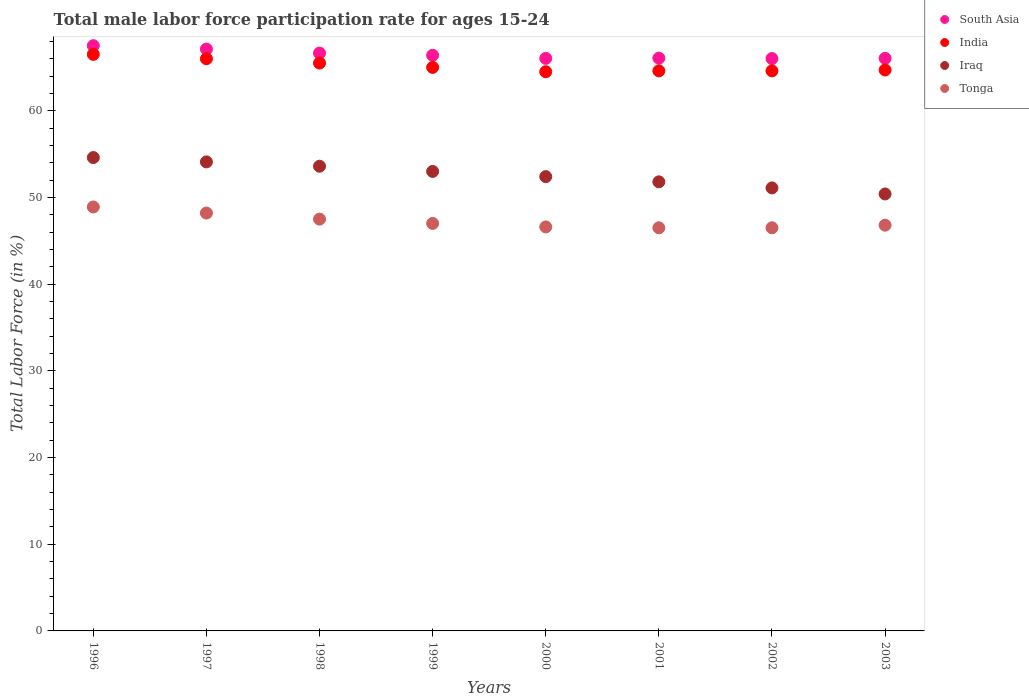What is the male labor force participation rate in Tonga in 1996?
Your answer should be compact. 48.9. Across all years, what is the maximum male labor force participation rate in Iraq?
Give a very brief answer. 54.6. Across all years, what is the minimum male labor force participation rate in Tonga?
Your response must be concise. 46.5. In which year was the male labor force participation rate in South Asia minimum?
Make the answer very short. 2002. What is the total male labor force participation rate in Iraq in the graph?
Give a very brief answer. 421. What is the difference between the male labor force participation rate in India in 2000 and the male labor force participation rate in Tonga in 1996?
Ensure brevity in your answer.  15.6. What is the average male labor force participation rate in South Asia per year?
Your response must be concise. 66.48. In the year 2000, what is the difference between the male labor force participation rate in Tonga and male labor force participation rate in Iraq?
Offer a very short reply. -5.8. What is the ratio of the male labor force participation rate in Iraq in 2000 to that in 2001?
Ensure brevity in your answer.  1.01. Is the male labor force participation rate in Tonga in 1999 less than that in 2002?
Ensure brevity in your answer.  No. Is the difference between the male labor force participation rate in Tonga in 1996 and 1999 greater than the difference between the male labor force participation rate in Iraq in 1996 and 1999?
Provide a succinct answer. Yes. What is the difference between the highest and the second highest male labor force participation rate in South Asia?
Ensure brevity in your answer.  0.39. What is the difference between the highest and the lowest male labor force participation rate in Iraq?
Ensure brevity in your answer.  4.2. Is the sum of the male labor force participation rate in India in 1999 and 2000 greater than the maximum male labor force participation rate in Tonga across all years?
Give a very brief answer. Yes. Is it the case that in every year, the sum of the male labor force participation rate in South Asia and male labor force participation rate in Tonga  is greater than the sum of male labor force participation rate in India and male labor force participation rate in Iraq?
Offer a very short reply. Yes. Does the male labor force participation rate in Iraq monotonically increase over the years?
Give a very brief answer. No. Is the male labor force participation rate in India strictly greater than the male labor force participation rate in South Asia over the years?
Offer a terse response. No. Is the male labor force participation rate in India strictly less than the male labor force participation rate in South Asia over the years?
Make the answer very short. Yes. What is the difference between two consecutive major ticks on the Y-axis?
Provide a short and direct response. 10. Are the values on the major ticks of Y-axis written in scientific E-notation?
Your answer should be very brief. No. How many legend labels are there?
Your answer should be very brief. 4. What is the title of the graph?
Provide a short and direct response. Total male labor force participation rate for ages 15-24. What is the Total Labor Force (in %) in South Asia in 1996?
Your response must be concise. 67.5. What is the Total Labor Force (in %) of India in 1996?
Provide a short and direct response. 66.5. What is the Total Labor Force (in %) of Iraq in 1996?
Make the answer very short. 54.6. What is the Total Labor Force (in %) in Tonga in 1996?
Keep it short and to the point. 48.9. What is the Total Labor Force (in %) in South Asia in 1997?
Give a very brief answer. 67.11. What is the Total Labor Force (in %) of Iraq in 1997?
Offer a very short reply. 54.1. What is the Total Labor Force (in %) of Tonga in 1997?
Your response must be concise. 48.2. What is the Total Labor Force (in %) in South Asia in 1998?
Provide a succinct answer. 66.65. What is the Total Labor Force (in %) in India in 1998?
Offer a very short reply. 65.5. What is the Total Labor Force (in %) of Iraq in 1998?
Make the answer very short. 53.6. What is the Total Labor Force (in %) of Tonga in 1998?
Your answer should be very brief. 47.5. What is the Total Labor Force (in %) of South Asia in 1999?
Your response must be concise. 66.4. What is the Total Labor Force (in %) of India in 1999?
Your answer should be compact. 65. What is the Total Labor Force (in %) in Iraq in 1999?
Give a very brief answer. 53. What is the Total Labor Force (in %) in Tonga in 1999?
Provide a short and direct response. 47. What is the Total Labor Force (in %) of South Asia in 2000?
Your answer should be compact. 66.04. What is the Total Labor Force (in %) of India in 2000?
Keep it short and to the point. 64.5. What is the Total Labor Force (in %) in Iraq in 2000?
Ensure brevity in your answer.  52.4. What is the Total Labor Force (in %) in Tonga in 2000?
Provide a succinct answer. 46.6. What is the Total Labor Force (in %) in South Asia in 2001?
Give a very brief answer. 66.07. What is the Total Labor Force (in %) of India in 2001?
Offer a terse response. 64.6. What is the Total Labor Force (in %) of Iraq in 2001?
Give a very brief answer. 51.8. What is the Total Labor Force (in %) of Tonga in 2001?
Make the answer very short. 46.5. What is the Total Labor Force (in %) in South Asia in 2002?
Give a very brief answer. 66.02. What is the Total Labor Force (in %) of India in 2002?
Your answer should be very brief. 64.6. What is the Total Labor Force (in %) in Iraq in 2002?
Ensure brevity in your answer.  51.1. What is the Total Labor Force (in %) of Tonga in 2002?
Offer a very short reply. 46.5. What is the Total Labor Force (in %) of South Asia in 2003?
Make the answer very short. 66.04. What is the Total Labor Force (in %) of India in 2003?
Offer a very short reply. 64.7. What is the Total Labor Force (in %) in Iraq in 2003?
Offer a terse response. 50.4. What is the Total Labor Force (in %) of Tonga in 2003?
Your answer should be compact. 46.8. Across all years, what is the maximum Total Labor Force (in %) in South Asia?
Provide a succinct answer. 67.5. Across all years, what is the maximum Total Labor Force (in %) in India?
Your response must be concise. 66.5. Across all years, what is the maximum Total Labor Force (in %) in Iraq?
Ensure brevity in your answer.  54.6. Across all years, what is the maximum Total Labor Force (in %) in Tonga?
Give a very brief answer. 48.9. Across all years, what is the minimum Total Labor Force (in %) in South Asia?
Your response must be concise. 66.02. Across all years, what is the minimum Total Labor Force (in %) in India?
Keep it short and to the point. 64.5. Across all years, what is the minimum Total Labor Force (in %) of Iraq?
Make the answer very short. 50.4. Across all years, what is the minimum Total Labor Force (in %) in Tonga?
Offer a terse response. 46.5. What is the total Total Labor Force (in %) in South Asia in the graph?
Provide a short and direct response. 531.83. What is the total Total Labor Force (in %) in India in the graph?
Make the answer very short. 521.4. What is the total Total Labor Force (in %) in Iraq in the graph?
Provide a short and direct response. 421. What is the total Total Labor Force (in %) in Tonga in the graph?
Provide a short and direct response. 378. What is the difference between the Total Labor Force (in %) in South Asia in 1996 and that in 1997?
Your answer should be very brief. 0.39. What is the difference between the Total Labor Force (in %) of Iraq in 1996 and that in 1997?
Offer a very short reply. 0.5. What is the difference between the Total Labor Force (in %) of South Asia in 1996 and that in 1998?
Provide a short and direct response. 0.86. What is the difference between the Total Labor Force (in %) of South Asia in 1996 and that in 1999?
Offer a terse response. 1.11. What is the difference between the Total Labor Force (in %) of Tonga in 1996 and that in 1999?
Give a very brief answer. 1.9. What is the difference between the Total Labor Force (in %) in South Asia in 1996 and that in 2000?
Provide a succinct answer. 1.47. What is the difference between the Total Labor Force (in %) of South Asia in 1996 and that in 2001?
Provide a short and direct response. 1.43. What is the difference between the Total Labor Force (in %) of India in 1996 and that in 2001?
Your response must be concise. 1.9. What is the difference between the Total Labor Force (in %) of Iraq in 1996 and that in 2001?
Ensure brevity in your answer.  2.8. What is the difference between the Total Labor Force (in %) of South Asia in 1996 and that in 2002?
Keep it short and to the point. 1.49. What is the difference between the Total Labor Force (in %) of Tonga in 1996 and that in 2002?
Your answer should be very brief. 2.4. What is the difference between the Total Labor Force (in %) of South Asia in 1996 and that in 2003?
Give a very brief answer. 1.46. What is the difference between the Total Labor Force (in %) in India in 1996 and that in 2003?
Give a very brief answer. 1.8. What is the difference between the Total Labor Force (in %) of Tonga in 1996 and that in 2003?
Keep it short and to the point. 2.1. What is the difference between the Total Labor Force (in %) in South Asia in 1997 and that in 1998?
Make the answer very short. 0.46. What is the difference between the Total Labor Force (in %) in South Asia in 1997 and that in 1999?
Your answer should be very brief. 0.72. What is the difference between the Total Labor Force (in %) in India in 1997 and that in 1999?
Your response must be concise. 1. What is the difference between the Total Labor Force (in %) of Tonga in 1997 and that in 1999?
Offer a very short reply. 1.2. What is the difference between the Total Labor Force (in %) of South Asia in 1997 and that in 2000?
Offer a terse response. 1.07. What is the difference between the Total Labor Force (in %) in India in 1997 and that in 2000?
Provide a succinct answer. 1.5. What is the difference between the Total Labor Force (in %) of South Asia in 1997 and that in 2001?
Offer a terse response. 1.04. What is the difference between the Total Labor Force (in %) of India in 1997 and that in 2001?
Make the answer very short. 1.4. What is the difference between the Total Labor Force (in %) of Tonga in 1997 and that in 2001?
Provide a short and direct response. 1.7. What is the difference between the Total Labor Force (in %) in South Asia in 1997 and that in 2002?
Provide a short and direct response. 1.09. What is the difference between the Total Labor Force (in %) of South Asia in 1997 and that in 2003?
Provide a short and direct response. 1.07. What is the difference between the Total Labor Force (in %) in India in 1997 and that in 2003?
Give a very brief answer. 1.3. What is the difference between the Total Labor Force (in %) of South Asia in 1998 and that in 1999?
Provide a succinct answer. 0.25. What is the difference between the Total Labor Force (in %) of South Asia in 1998 and that in 2000?
Keep it short and to the point. 0.61. What is the difference between the Total Labor Force (in %) of Iraq in 1998 and that in 2000?
Your response must be concise. 1.2. What is the difference between the Total Labor Force (in %) in South Asia in 1998 and that in 2001?
Your response must be concise. 0.58. What is the difference between the Total Labor Force (in %) of India in 1998 and that in 2001?
Give a very brief answer. 0.9. What is the difference between the Total Labor Force (in %) of Iraq in 1998 and that in 2001?
Keep it short and to the point. 1.8. What is the difference between the Total Labor Force (in %) of South Asia in 1998 and that in 2002?
Provide a short and direct response. 0.63. What is the difference between the Total Labor Force (in %) in Iraq in 1998 and that in 2002?
Provide a succinct answer. 2.5. What is the difference between the Total Labor Force (in %) of South Asia in 1998 and that in 2003?
Your response must be concise. 0.61. What is the difference between the Total Labor Force (in %) in Iraq in 1998 and that in 2003?
Provide a short and direct response. 3.2. What is the difference between the Total Labor Force (in %) in South Asia in 1999 and that in 2000?
Your answer should be compact. 0.36. What is the difference between the Total Labor Force (in %) of India in 1999 and that in 2000?
Your answer should be very brief. 0.5. What is the difference between the Total Labor Force (in %) in Iraq in 1999 and that in 2000?
Give a very brief answer. 0.6. What is the difference between the Total Labor Force (in %) of Tonga in 1999 and that in 2000?
Give a very brief answer. 0.4. What is the difference between the Total Labor Force (in %) of South Asia in 1999 and that in 2001?
Offer a very short reply. 0.33. What is the difference between the Total Labor Force (in %) in South Asia in 1999 and that in 2002?
Your response must be concise. 0.38. What is the difference between the Total Labor Force (in %) of India in 1999 and that in 2002?
Make the answer very short. 0.4. What is the difference between the Total Labor Force (in %) of Tonga in 1999 and that in 2002?
Provide a short and direct response. 0.5. What is the difference between the Total Labor Force (in %) of South Asia in 1999 and that in 2003?
Your answer should be compact. 0.35. What is the difference between the Total Labor Force (in %) in India in 1999 and that in 2003?
Ensure brevity in your answer.  0.3. What is the difference between the Total Labor Force (in %) in Iraq in 1999 and that in 2003?
Ensure brevity in your answer.  2.6. What is the difference between the Total Labor Force (in %) of Tonga in 1999 and that in 2003?
Offer a terse response. 0.2. What is the difference between the Total Labor Force (in %) in South Asia in 2000 and that in 2001?
Offer a terse response. -0.03. What is the difference between the Total Labor Force (in %) in India in 2000 and that in 2001?
Your answer should be compact. -0.1. What is the difference between the Total Labor Force (in %) of Iraq in 2000 and that in 2001?
Offer a terse response. 0.6. What is the difference between the Total Labor Force (in %) of Tonga in 2000 and that in 2001?
Give a very brief answer. 0.1. What is the difference between the Total Labor Force (in %) in South Asia in 2000 and that in 2002?
Offer a terse response. 0.02. What is the difference between the Total Labor Force (in %) in India in 2000 and that in 2002?
Provide a succinct answer. -0.1. What is the difference between the Total Labor Force (in %) in Iraq in 2000 and that in 2002?
Make the answer very short. 1.3. What is the difference between the Total Labor Force (in %) in Tonga in 2000 and that in 2002?
Make the answer very short. 0.1. What is the difference between the Total Labor Force (in %) in South Asia in 2000 and that in 2003?
Provide a succinct answer. -0. What is the difference between the Total Labor Force (in %) in Iraq in 2000 and that in 2003?
Your response must be concise. 2. What is the difference between the Total Labor Force (in %) in South Asia in 2001 and that in 2002?
Make the answer very short. 0.05. What is the difference between the Total Labor Force (in %) of Iraq in 2001 and that in 2002?
Keep it short and to the point. 0.7. What is the difference between the Total Labor Force (in %) of South Asia in 2001 and that in 2003?
Keep it short and to the point. 0.03. What is the difference between the Total Labor Force (in %) of Iraq in 2001 and that in 2003?
Your response must be concise. 1.4. What is the difference between the Total Labor Force (in %) in Tonga in 2001 and that in 2003?
Ensure brevity in your answer.  -0.3. What is the difference between the Total Labor Force (in %) in South Asia in 2002 and that in 2003?
Offer a very short reply. -0.02. What is the difference between the Total Labor Force (in %) in India in 2002 and that in 2003?
Provide a short and direct response. -0.1. What is the difference between the Total Labor Force (in %) in South Asia in 1996 and the Total Labor Force (in %) in India in 1997?
Your answer should be compact. 1.5. What is the difference between the Total Labor Force (in %) of South Asia in 1996 and the Total Labor Force (in %) of Iraq in 1997?
Make the answer very short. 13.4. What is the difference between the Total Labor Force (in %) of South Asia in 1996 and the Total Labor Force (in %) of Tonga in 1997?
Give a very brief answer. 19.3. What is the difference between the Total Labor Force (in %) of India in 1996 and the Total Labor Force (in %) of Tonga in 1997?
Offer a very short reply. 18.3. What is the difference between the Total Labor Force (in %) in South Asia in 1996 and the Total Labor Force (in %) in India in 1998?
Your response must be concise. 2. What is the difference between the Total Labor Force (in %) of South Asia in 1996 and the Total Labor Force (in %) of Iraq in 1998?
Provide a short and direct response. 13.9. What is the difference between the Total Labor Force (in %) in South Asia in 1996 and the Total Labor Force (in %) in Tonga in 1998?
Your response must be concise. 20. What is the difference between the Total Labor Force (in %) of India in 1996 and the Total Labor Force (in %) of Iraq in 1998?
Offer a very short reply. 12.9. What is the difference between the Total Labor Force (in %) in South Asia in 1996 and the Total Labor Force (in %) in India in 1999?
Make the answer very short. 2.5. What is the difference between the Total Labor Force (in %) in South Asia in 1996 and the Total Labor Force (in %) in Iraq in 1999?
Your response must be concise. 14.5. What is the difference between the Total Labor Force (in %) of South Asia in 1996 and the Total Labor Force (in %) of Tonga in 1999?
Keep it short and to the point. 20.5. What is the difference between the Total Labor Force (in %) of India in 1996 and the Total Labor Force (in %) of Tonga in 1999?
Your response must be concise. 19.5. What is the difference between the Total Labor Force (in %) of Iraq in 1996 and the Total Labor Force (in %) of Tonga in 1999?
Provide a short and direct response. 7.6. What is the difference between the Total Labor Force (in %) in South Asia in 1996 and the Total Labor Force (in %) in India in 2000?
Give a very brief answer. 3. What is the difference between the Total Labor Force (in %) in South Asia in 1996 and the Total Labor Force (in %) in Iraq in 2000?
Offer a very short reply. 15.1. What is the difference between the Total Labor Force (in %) in South Asia in 1996 and the Total Labor Force (in %) in Tonga in 2000?
Provide a succinct answer. 20.9. What is the difference between the Total Labor Force (in %) of India in 1996 and the Total Labor Force (in %) of Iraq in 2000?
Your answer should be compact. 14.1. What is the difference between the Total Labor Force (in %) of Iraq in 1996 and the Total Labor Force (in %) of Tonga in 2000?
Offer a very short reply. 8. What is the difference between the Total Labor Force (in %) of South Asia in 1996 and the Total Labor Force (in %) of India in 2001?
Your response must be concise. 2.9. What is the difference between the Total Labor Force (in %) in South Asia in 1996 and the Total Labor Force (in %) in Iraq in 2001?
Ensure brevity in your answer.  15.7. What is the difference between the Total Labor Force (in %) in South Asia in 1996 and the Total Labor Force (in %) in Tonga in 2001?
Give a very brief answer. 21. What is the difference between the Total Labor Force (in %) in India in 1996 and the Total Labor Force (in %) in Iraq in 2001?
Offer a terse response. 14.7. What is the difference between the Total Labor Force (in %) of Iraq in 1996 and the Total Labor Force (in %) of Tonga in 2001?
Provide a succinct answer. 8.1. What is the difference between the Total Labor Force (in %) of South Asia in 1996 and the Total Labor Force (in %) of India in 2002?
Offer a very short reply. 2.9. What is the difference between the Total Labor Force (in %) of South Asia in 1996 and the Total Labor Force (in %) of Iraq in 2002?
Keep it short and to the point. 16.4. What is the difference between the Total Labor Force (in %) in South Asia in 1996 and the Total Labor Force (in %) in Tonga in 2002?
Offer a terse response. 21. What is the difference between the Total Labor Force (in %) in Iraq in 1996 and the Total Labor Force (in %) in Tonga in 2002?
Your answer should be very brief. 8.1. What is the difference between the Total Labor Force (in %) of South Asia in 1996 and the Total Labor Force (in %) of India in 2003?
Ensure brevity in your answer.  2.8. What is the difference between the Total Labor Force (in %) in South Asia in 1996 and the Total Labor Force (in %) in Iraq in 2003?
Your answer should be compact. 17.1. What is the difference between the Total Labor Force (in %) in South Asia in 1996 and the Total Labor Force (in %) in Tonga in 2003?
Offer a terse response. 20.7. What is the difference between the Total Labor Force (in %) of India in 1996 and the Total Labor Force (in %) of Tonga in 2003?
Make the answer very short. 19.7. What is the difference between the Total Labor Force (in %) of Iraq in 1996 and the Total Labor Force (in %) of Tonga in 2003?
Keep it short and to the point. 7.8. What is the difference between the Total Labor Force (in %) of South Asia in 1997 and the Total Labor Force (in %) of India in 1998?
Offer a terse response. 1.61. What is the difference between the Total Labor Force (in %) in South Asia in 1997 and the Total Labor Force (in %) in Iraq in 1998?
Keep it short and to the point. 13.51. What is the difference between the Total Labor Force (in %) in South Asia in 1997 and the Total Labor Force (in %) in Tonga in 1998?
Offer a terse response. 19.61. What is the difference between the Total Labor Force (in %) in India in 1997 and the Total Labor Force (in %) in Iraq in 1998?
Ensure brevity in your answer.  12.4. What is the difference between the Total Labor Force (in %) in India in 1997 and the Total Labor Force (in %) in Tonga in 1998?
Provide a short and direct response. 18.5. What is the difference between the Total Labor Force (in %) in Iraq in 1997 and the Total Labor Force (in %) in Tonga in 1998?
Your answer should be compact. 6.6. What is the difference between the Total Labor Force (in %) in South Asia in 1997 and the Total Labor Force (in %) in India in 1999?
Offer a terse response. 2.11. What is the difference between the Total Labor Force (in %) of South Asia in 1997 and the Total Labor Force (in %) of Iraq in 1999?
Offer a terse response. 14.11. What is the difference between the Total Labor Force (in %) of South Asia in 1997 and the Total Labor Force (in %) of Tonga in 1999?
Provide a succinct answer. 20.11. What is the difference between the Total Labor Force (in %) of India in 1997 and the Total Labor Force (in %) of Iraq in 1999?
Your answer should be very brief. 13. What is the difference between the Total Labor Force (in %) of India in 1997 and the Total Labor Force (in %) of Tonga in 1999?
Give a very brief answer. 19. What is the difference between the Total Labor Force (in %) of Iraq in 1997 and the Total Labor Force (in %) of Tonga in 1999?
Keep it short and to the point. 7.1. What is the difference between the Total Labor Force (in %) of South Asia in 1997 and the Total Labor Force (in %) of India in 2000?
Keep it short and to the point. 2.61. What is the difference between the Total Labor Force (in %) in South Asia in 1997 and the Total Labor Force (in %) in Iraq in 2000?
Ensure brevity in your answer.  14.71. What is the difference between the Total Labor Force (in %) of South Asia in 1997 and the Total Labor Force (in %) of Tonga in 2000?
Your answer should be compact. 20.51. What is the difference between the Total Labor Force (in %) of South Asia in 1997 and the Total Labor Force (in %) of India in 2001?
Offer a very short reply. 2.51. What is the difference between the Total Labor Force (in %) in South Asia in 1997 and the Total Labor Force (in %) in Iraq in 2001?
Your answer should be very brief. 15.31. What is the difference between the Total Labor Force (in %) in South Asia in 1997 and the Total Labor Force (in %) in Tonga in 2001?
Offer a terse response. 20.61. What is the difference between the Total Labor Force (in %) in Iraq in 1997 and the Total Labor Force (in %) in Tonga in 2001?
Your response must be concise. 7.6. What is the difference between the Total Labor Force (in %) of South Asia in 1997 and the Total Labor Force (in %) of India in 2002?
Offer a very short reply. 2.51. What is the difference between the Total Labor Force (in %) of South Asia in 1997 and the Total Labor Force (in %) of Iraq in 2002?
Provide a short and direct response. 16.01. What is the difference between the Total Labor Force (in %) of South Asia in 1997 and the Total Labor Force (in %) of Tonga in 2002?
Provide a short and direct response. 20.61. What is the difference between the Total Labor Force (in %) in India in 1997 and the Total Labor Force (in %) in Iraq in 2002?
Make the answer very short. 14.9. What is the difference between the Total Labor Force (in %) of Iraq in 1997 and the Total Labor Force (in %) of Tonga in 2002?
Provide a succinct answer. 7.6. What is the difference between the Total Labor Force (in %) of South Asia in 1997 and the Total Labor Force (in %) of India in 2003?
Keep it short and to the point. 2.41. What is the difference between the Total Labor Force (in %) of South Asia in 1997 and the Total Labor Force (in %) of Iraq in 2003?
Your answer should be compact. 16.71. What is the difference between the Total Labor Force (in %) of South Asia in 1997 and the Total Labor Force (in %) of Tonga in 2003?
Provide a short and direct response. 20.31. What is the difference between the Total Labor Force (in %) in South Asia in 1998 and the Total Labor Force (in %) in India in 1999?
Your answer should be compact. 1.65. What is the difference between the Total Labor Force (in %) in South Asia in 1998 and the Total Labor Force (in %) in Iraq in 1999?
Keep it short and to the point. 13.65. What is the difference between the Total Labor Force (in %) of South Asia in 1998 and the Total Labor Force (in %) of Tonga in 1999?
Provide a succinct answer. 19.65. What is the difference between the Total Labor Force (in %) of India in 1998 and the Total Labor Force (in %) of Tonga in 1999?
Ensure brevity in your answer.  18.5. What is the difference between the Total Labor Force (in %) in South Asia in 1998 and the Total Labor Force (in %) in India in 2000?
Make the answer very short. 2.15. What is the difference between the Total Labor Force (in %) of South Asia in 1998 and the Total Labor Force (in %) of Iraq in 2000?
Give a very brief answer. 14.25. What is the difference between the Total Labor Force (in %) of South Asia in 1998 and the Total Labor Force (in %) of Tonga in 2000?
Your answer should be very brief. 20.05. What is the difference between the Total Labor Force (in %) in India in 1998 and the Total Labor Force (in %) in Iraq in 2000?
Offer a very short reply. 13.1. What is the difference between the Total Labor Force (in %) in India in 1998 and the Total Labor Force (in %) in Tonga in 2000?
Make the answer very short. 18.9. What is the difference between the Total Labor Force (in %) in South Asia in 1998 and the Total Labor Force (in %) in India in 2001?
Give a very brief answer. 2.05. What is the difference between the Total Labor Force (in %) of South Asia in 1998 and the Total Labor Force (in %) of Iraq in 2001?
Your response must be concise. 14.85. What is the difference between the Total Labor Force (in %) of South Asia in 1998 and the Total Labor Force (in %) of Tonga in 2001?
Ensure brevity in your answer.  20.15. What is the difference between the Total Labor Force (in %) in India in 1998 and the Total Labor Force (in %) in Iraq in 2001?
Provide a succinct answer. 13.7. What is the difference between the Total Labor Force (in %) in South Asia in 1998 and the Total Labor Force (in %) in India in 2002?
Your answer should be very brief. 2.05. What is the difference between the Total Labor Force (in %) in South Asia in 1998 and the Total Labor Force (in %) in Iraq in 2002?
Offer a terse response. 15.55. What is the difference between the Total Labor Force (in %) of South Asia in 1998 and the Total Labor Force (in %) of Tonga in 2002?
Provide a short and direct response. 20.15. What is the difference between the Total Labor Force (in %) in India in 1998 and the Total Labor Force (in %) in Iraq in 2002?
Make the answer very short. 14.4. What is the difference between the Total Labor Force (in %) of South Asia in 1998 and the Total Labor Force (in %) of India in 2003?
Your answer should be very brief. 1.95. What is the difference between the Total Labor Force (in %) in South Asia in 1998 and the Total Labor Force (in %) in Iraq in 2003?
Your answer should be compact. 16.25. What is the difference between the Total Labor Force (in %) of South Asia in 1998 and the Total Labor Force (in %) of Tonga in 2003?
Your answer should be very brief. 19.85. What is the difference between the Total Labor Force (in %) in South Asia in 1999 and the Total Labor Force (in %) in India in 2000?
Provide a succinct answer. 1.9. What is the difference between the Total Labor Force (in %) in South Asia in 1999 and the Total Labor Force (in %) in Iraq in 2000?
Give a very brief answer. 14. What is the difference between the Total Labor Force (in %) of South Asia in 1999 and the Total Labor Force (in %) of Tonga in 2000?
Your answer should be very brief. 19.8. What is the difference between the Total Labor Force (in %) in India in 1999 and the Total Labor Force (in %) in Iraq in 2000?
Give a very brief answer. 12.6. What is the difference between the Total Labor Force (in %) in Iraq in 1999 and the Total Labor Force (in %) in Tonga in 2000?
Ensure brevity in your answer.  6.4. What is the difference between the Total Labor Force (in %) in South Asia in 1999 and the Total Labor Force (in %) in India in 2001?
Ensure brevity in your answer.  1.8. What is the difference between the Total Labor Force (in %) of South Asia in 1999 and the Total Labor Force (in %) of Iraq in 2001?
Offer a very short reply. 14.6. What is the difference between the Total Labor Force (in %) of South Asia in 1999 and the Total Labor Force (in %) of Tonga in 2001?
Keep it short and to the point. 19.9. What is the difference between the Total Labor Force (in %) of India in 1999 and the Total Labor Force (in %) of Tonga in 2001?
Give a very brief answer. 18.5. What is the difference between the Total Labor Force (in %) in Iraq in 1999 and the Total Labor Force (in %) in Tonga in 2001?
Offer a terse response. 6.5. What is the difference between the Total Labor Force (in %) in South Asia in 1999 and the Total Labor Force (in %) in India in 2002?
Provide a short and direct response. 1.8. What is the difference between the Total Labor Force (in %) in South Asia in 1999 and the Total Labor Force (in %) in Iraq in 2002?
Offer a terse response. 15.3. What is the difference between the Total Labor Force (in %) of South Asia in 1999 and the Total Labor Force (in %) of Tonga in 2002?
Provide a short and direct response. 19.9. What is the difference between the Total Labor Force (in %) in Iraq in 1999 and the Total Labor Force (in %) in Tonga in 2002?
Ensure brevity in your answer.  6.5. What is the difference between the Total Labor Force (in %) of South Asia in 1999 and the Total Labor Force (in %) of India in 2003?
Your answer should be compact. 1.7. What is the difference between the Total Labor Force (in %) in South Asia in 1999 and the Total Labor Force (in %) in Iraq in 2003?
Provide a succinct answer. 16. What is the difference between the Total Labor Force (in %) in South Asia in 1999 and the Total Labor Force (in %) in Tonga in 2003?
Ensure brevity in your answer.  19.6. What is the difference between the Total Labor Force (in %) in India in 1999 and the Total Labor Force (in %) in Iraq in 2003?
Ensure brevity in your answer.  14.6. What is the difference between the Total Labor Force (in %) in Iraq in 1999 and the Total Labor Force (in %) in Tonga in 2003?
Offer a very short reply. 6.2. What is the difference between the Total Labor Force (in %) in South Asia in 2000 and the Total Labor Force (in %) in India in 2001?
Give a very brief answer. 1.44. What is the difference between the Total Labor Force (in %) of South Asia in 2000 and the Total Labor Force (in %) of Iraq in 2001?
Provide a short and direct response. 14.24. What is the difference between the Total Labor Force (in %) of South Asia in 2000 and the Total Labor Force (in %) of Tonga in 2001?
Give a very brief answer. 19.54. What is the difference between the Total Labor Force (in %) of India in 2000 and the Total Labor Force (in %) of Iraq in 2001?
Your answer should be very brief. 12.7. What is the difference between the Total Labor Force (in %) in South Asia in 2000 and the Total Labor Force (in %) in India in 2002?
Offer a very short reply. 1.44. What is the difference between the Total Labor Force (in %) of South Asia in 2000 and the Total Labor Force (in %) of Iraq in 2002?
Offer a terse response. 14.94. What is the difference between the Total Labor Force (in %) of South Asia in 2000 and the Total Labor Force (in %) of Tonga in 2002?
Your response must be concise. 19.54. What is the difference between the Total Labor Force (in %) of India in 2000 and the Total Labor Force (in %) of Tonga in 2002?
Offer a very short reply. 18. What is the difference between the Total Labor Force (in %) of Iraq in 2000 and the Total Labor Force (in %) of Tonga in 2002?
Ensure brevity in your answer.  5.9. What is the difference between the Total Labor Force (in %) of South Asia in 2000 and the Total Labor Force (in %) of India in 2003?
Offer a terse response. 1.34. What is the difference between the Total Labor Force (in %) in South Asia in 2000 and the Total Labor Force (in %) in Iraq in 2003?
Ensure brevity in your answer.  15.64. What is the difference between the Total Labor Force (in %) of South Asia in 2000 and the Total Labor Force (in %) of Tonga in 2003?
Keep it short and to the point. 19.24. What is the difference between the Total Labor Force (in %) of India in 2000 and the Total Labor Force (in %) of Iraq in 2003?
Provide a short and direct response. 14.1. What is the difference between the Total Labor Force (in %) of India in 2000 and the Total Labor Force (in %) of Tonga in 2003?
Your answer should be compact. 17.7. What is the difference between the Total Labor Force (in %) of Iraq in 2000 and the Total Labor Force (in %) of Tonga in 2003?
Offer a terse response. 5.6. What is the difference between the Total Labor Force (in %) in South Asia in 2001 and the Total Labor Force (in %) in India in 2002?
Provide a short and direct response. 1.47. What is the difference between the Total Labor Force (in %) of South Asia in 2001 and the Total Labor Force (in %) of Iraq in 2002?
Give a very brief answer. 14.97. What is the difference between the Total Labor Force (in %) of South Asia in 2001 and the Total Labor Force (in %) of Tonga in 2002?
Give a very brief answer. 19.57. What is the difference between the Total Labor Force (in %) of India in 2001 and the Total Labor Force (in %) of Iraq in 2002?
Your response must be concise. 13.5. What is the difference between the Total Labor Force (in %) in South Asia in 2001 and the Total Labor Force (in %) in India in 2003?
Offer a very short reply. 1.37. What is the difference between the Total Labor Force (in %) in South Asia in 2001 and the Total Labor Force (in %) in Iraq in 2003?
Provide a short and direct response. 15.67. What is the difference between the Total Labor Force (in %) in South Asia in 2001 and the Total Labor Force (in %) in Tonga in 2003?
Give a very brief answer. 19.27. What is the difference between the Total Labor Force (in %) in India in 2001 and the Total Labor Force (in %) in Iraq in 2003?
Provide a succinct answer. 14.2. What is the difference between the Total Labor Force (in %) in India in 2001 and the Total Labor Force (in %) in Tonga in 2003?
Your answer should be compact. 17.8. What is the difference between the Total Labor Force (in %) in Iraq in 2001 and the Total Labor Force (in %) in Tonga in 2003?
Your answer should be very brief. 5. What is the difference between the Total Labor Force (in %) in South Asia in 2002 and the Total Labor Force (in %) in India in 2003?
Keep it short and to the point. 1.32. What is the difference between the Total Labor Force (in %) of South Asia in 2002 and the Total Labor Force (in %) of Iraq in 2003?
Keep it short and to the point. 15.62. What is the difference between the Total Labor Force (in %) of South Asia in 2002 and the Total Labor Force (in %) of Tonga in 2003?
Keep it short and to the point. 19.22. What is the difference between the Total Labor Force (in %) of India in 2002 and the Total Labor Force (in %) of Tonga in 2003?
Your answer should be compact. 17.8. What is the difference between the Total Labor Force (in %) of Iraq in 2002 and the Total Labor Force (in %) of Tonga in 2003?
Make the answer very short. 4.3. What is the average Total Labor Force (in %) in South Asia per year?
Your response must be concise. 66.48. What is the average Total Labor Force (in %) in India per year?
Provide a short and direct response. 65.17. What is the average Total Labor Force (in %) of Iraq per year?
Keep it short and to the point. 52.62. What is the average Total Labor Force (in %) in Tonga per year?
Your answer should be very brief. 47.25. In the year 1996, what is the difference between the Total Labor Force (in %) in South Asia and Total Labor Force (in %) in Iraq?
Provide a short and direct response. 12.9. In the year 1996, what is the difference between the Total Labor Force (in %) in South Asia and Total Labor Force (in %) in Tonga?
Provide a succinct answer. 18.6. In the year 1996, what is the difference between the Total Labor Force (in %) in India and Total Labor Force (in %) in Iraq?
Your response must be concise. 11.9. In the year 1996, what is the difference between the Total Labor Force (in %) in India and Total Labor Force (in %) in Tonga?
Make the answer very short. 17.6. In the year 1996, what is the difference between the Total Labor Force (in %) of Iraq and Total Labor Force (in %) of Tonga?
Your answer should be very brief. 5.7. In the year 1997, what is the difference between the Total Labor Force (in %) in South Asia and Total Labor Force (in %) in India?
Provide a short and direct response. 1.11. In the year 1997, what is the difference between the Total Labor Force (in %) in South Asia and Total Labor Force (in %) in Iraq?
Your answer should be very brief. 13.01. In the year 1997, what is the difference between the Total Labor Force (in %) of South Asia and Total Labor Force (in %) of Tonga?
Offer a very short reply. 18.91. In the year 1997, what is the difference between the Total Labor Force (in %) of India and Total Labor Force (in %) of Tonga?
Give a very brief answer. 17.8. In the year 1997, what is the difference between the Total Labor Force (in %) of Iraq and Total Labor Force (in %) of Tonga?
Keep it short and to the point. 5.9. In the year 1998, what is the difference between the Total Labor Force (in %) in South Asia and Total Labor Force (in %) in India?
Provide a succinct answer. 1.15. In the year 1998, what is the difference between the Total Labor Force (in %) of South Asia and Total Labor Force (in %) of Iraq?
Provide a succinct answer. 13.05. In the year 1998, what is the difference between the Total Labor Force (in %) of South Asia and Total Labor Force (in %) of Tonga?
Your answer should be compact. 19.15. In the year 1998, what is the difference between the Total Labor Force (in %) of India and Total Labor Force (in %) of Tonga?
Your answer should be very brief. 18. In the year 1998, what is the difference between the Total Labor Force (in %) of Iraq and Total Labor Force (in %) of Tonga?
Give a very brief answer. 6.1. In the year 1999, what is the difference between the Total Labor Force (in %) of South Asia and Total Labor Force (in %) of India?
Offer a very short reply. 1.4. In the year 1999, what is the difference between the Total Labor Force (in %) of South Asia and Total Labor Force (in %) of Iraq?
Your answer should be compact. 13.4. In the year 1999, what is the difference between the Total Labor Force (in %) in South Asia and Total Labor Force (in %) in Tonga?
Offer a very short reply. 19.4. In the year 1999, what is the difference between the Total Labor Force (in %) of India and Total Labor Force (in %) of Tonga?
Your answer should be very brief. 18. In the year 1999, what is the difference between the Total Labor Force (in %) of Iraq and Total Labor Force (in %) of Tonga?
Ensure brevity in your answer.  6. In the year 2000, what is the difference between the Total Labor Force (in %) in South Asia and Total Labor Force (in %) in India?
Provide a succinct answer. 1.54. In the year 2000, what is the difference between the Total Labor Force (in %) in South Asia and Total Labor Force (in %) in Iraq?
Make the answer very short. 13.64. In the year 2000, what is the difference between the Total Labor Force (in %) in South Asia and Total Labor Force (in %) in Tonga?
Give a very brief answer. 19.44. In the year 2000, what is the difference between the Total Labor Force (in %) of India and Total Labor Force (in %) of Iraq?
Ensure brevity in your answer.  12.1. In the year 2000, what is the difference between the Total Labor Force (in %) of Iraq and Total Labor Force (in %) of Tonga?
Provide a short and direct response. 5.8. In the year 2001, what is the difference between the Total Labor Force (in %) in South Asia and Total Labor Force (in %) in India?
Make the answer very short. 1.47. In the year 2001, what is the difference between the Total Labor Force (in %) of South Asia and Total Labor Force (in %) of Iraq?
Give a very brief answer. 14.27. In the year 2001, what is the difference between the Total Labor Force (in %) in South Asia and Total Labor Force (in %) in Tonga?
Your answer should be very brief. 19.57. In the year 2001, what is the difference between the Total Labor Force (in %) in India and Total Labor Force (in %) in Iraq?
Keep it short and to the point. 12.8. In the year 2001, what is the difference between the Total Labor Force (in %) of India and Total Labor Force (in %) of Tonga?
Keep it short and to the point. 18.1. In the year 2002, what is the difference between the Total Labor Force (in %) in South Asia and Total Labor Force (in %) in India?
Provide a short and direct response. 1.42. In the year 2002, what is the difference between the Total Labor Force (in %) of South Asia and Total Labor Force (in %) of Iraq?
Offer a terse response. 14.92. In the year 2002, what is the difference between the Total Labor Force (in %) in South Asia and Total Labor Force (in %) in Tonga?
Provide a short and direct response. 19.52. In the year 2003, what is the difference between the Total Labor Force (in %) of South Asia and Total Labor Force (in %) of India?
Ensure brevity in your answer.  1.34. In the year 2003, what is the difference between the Total Labor Force (in %) of South Asia and Total Labor Force (in %) of Iraq?
Offer a terse response. 15.64. In the year 2003, what is the difference between the Total Labor Force (in %) of South Asia and Total Labor Force (in %) of Tonga?
Provide a short and direct response. 19.24. In the year 2003, what is the difference between the Total Labor Force (in %) in India and Total Labor Force (in %) in Iraq?
Keep it short and to the point. 14.3. In the year 2003, what is the difference between the Total Labor Force (in %) in India and Total Labor Force (in %) in Tonga?
Your response must be concise. 17.9. In the year 2003, what is the difference between the Total Labor Force (in %) in Iraq and Total Labor Force (in %) in Tonga?
Provide a succinct answer. 3.6. What is the ratio of the Total Labor Force (in %) in South Asia in 1996 to that in 1997?
Offer a terse response. 1.01. What is the ratio of the Total Labor Force (in %) of India in 1996 to that in 1997?
Your answer should be very brief. 1.01. What is the ratio of the Total Labor Force (in %) of Iraq in 1996 to that in 1997?
Provide a short and direct response. 1.01. What is the ratio of the Total Labor Force (in %) in Tonga in 1996 to that in 1997?
Provide a succinct answer. 1.01. What is the ratio of the Total Labor Force (in %) in South Asia in 1996 to that in 1998?
Provide a succinct answer. 1.01. What is the ratio of the Total Labor Force (in %) of India in 1996 to that in 1998?
Your answer should be compact. 1.02. What is the ratio of the Total Labor Force (in %) of Iraq in 1996 to that in 1998?
Provide a short and direct response. 1.02. What is the ratio of the Total Labor Force (in %) of Tonga in 1996 to that in 1998?
Ensure brevity in your answer.  1.03. What is the ratio of the Total Labor Force (in %) in South Asia in 1996 to that in 1999?
Give a very brief answer. 1.02. What is the ratio of the Total Labor Force (in %) in India in 1996 to that in 1999?
Offer a very short reply. 1.02. What is the ratio of the Total Labor Force (in %) in Iraq in 1996 to that in 1999?
Make the answer very short. 1.03. What is the ratio of the Total Labor Force (in %) in Tonga in 1996 to that in 1999?
Offer a very short reply. 1.04. What is the ratio of the Total Labor Force (in %) in South Asia in 1996 to that in 2000?
Ensure brevity in your answer.  1.02. What is the ratio of the Total Labor Force (in %) of India in 1996 to that in 2000?
Make the answer very short. 1.03. What is the ratio of the Total Labor Force (in %) in Iraq in 1996 to that in 2000?
Make the answer very short. 1.04. What is the ratio of the Total Labor Force (in %) of Tonga in 1996 to that in 2000?
Ensure brevity in your answer.  1.05. What is the ratio of the Total Labor Force (in %) of South Asia in 1996 to that in 2001?
Provide a short and direct response. 1.02. What is the ratio of the Total Labor Force (in %) in India in 1996 to that in 2001?
Your response must be concise. 1.03. What is the ratio of the Total Labor Force (in %) in Iraq in 1996 to that in 2001?
Your answer should be very brief. 1.05. What is the ratio of the Total Labor Force (in %) of Tonga in 1996 to that in 2001?
Your answer should be very brief. 1.05. What is the ratio of the Total Labor Force (in %) in South Asia in 1996 to that in 2002?
Your response must be concise. 1.02. What is the ratio of the Total Labor Force (in %) in India in 1996 to that in 2002?
Offer a very short reply. 1.03. What is the ratio of the Total Labor Force (in %) in Iraq in 1996 to that in 2002?
Your answer should be very brief. 1.07. What is the ratio of the Total Labor Force (in %) of Tonga in 1996 to that in 2002?
Provide a short and direct response. 1.05. What is the ratio of the Total Labor Force (in %) in South Asia in 1996 to that in 2003?
Your answer should be very brief. 1.02. What is the ratio of the Total Labor Force (in %) of India in 1996 to that in 2003?
Provide a succinct answer. 1.03. What is the ratio of the Total Labor Force (in %) of Iraq in 1996 to that in 2003?
Keep it short and to the point. 1.08. What is the ratio of the Total Labor Force (in %) of Tonga in 1996 to that in 2003?
Provide a succinct answer. 1.04. What is the ratio of the Total Labor Force (in %) of South Asia in 1997 to that in 1998?
Ensure brevity in your answer.  1.01. What is the ratio of the Total Labor Force (in %) of India in 1997 to that in 1998?
Keep it short and to the point. 1.01. What is the ratio of the Total Labor Force (in %) in Iraq in 1997 to that in 1998?
Your answer should be very brief. 1.01. What is the ratio of the Total Labor Force (in %) of Tonga in 1997 to that in 1998?
Provide a short and direct response. 1.01. What is the ratio of the Total Labor Force (in %) in South Asia in 1997 to that in 1999?
Your answer should be very brief. 1.01. What is the ratio of the Total Labor Force (in %) of India in 1997 to that in 1999?
Your response must be concise. 1.02. What is the ratio of the Total Labor Force (in %) of Iraq in 1997 to that in 1999?
Provide a succinct answer. 1.02. What is the ratio of the Total Labor Force (in %) in Tonga in 1997 to that in 1999?
Offer a terse response. 1.03. What is the ratio of the Total Labor Force (in %) of South Asia in 1997 to that in 2000?
Your answer should be very brief. 1.02. What is the ratio of the Total Labor Force (in %) in India in 1997 to that in 2000?
Your response must be concise. 1.02. What is the ratio of the Total Labor Force (in %) of Iraq in 1997 to that in 2000?
Provide a short and direct response. 1.03. What is the ratio of the Total Labor Force (in %) of Tonga in 1997 to that in 2000?
Provide a short and direct response. 1.03. What is the ratio of the Total Labor Force (in %) in South Asia in 1997 to that in 2001?
Provide a short and direct response. 1.02. What is the ratio of the Total Labor Force (in %) in India in 1997 to that in 2001?
Provide a short and direct response. 1.02. What is the ratio of the Total Labor Force (in %) in Iraq in 1997 to that in 2001?
Make the answer very short. 1.04. What is the ratio of the Total Labor Force (in %) in Tonga in 1997 to that in 2001?
Give a very brief answer. 1.04. What is the ratio of the Total Labor Force (in %) of South Asia in 1997 to that in 2002?
Offer a terse response. 1.02. What is the ratio of the Total Labor Force (in %) of India in 1997 to that in 2002?
Offer a very short reply. 1.02. What is the ratio of the Total Labor Force (in %) in Iraq in 1997 to that in 2002?
Your answer should be very brief. 1.06. What is the ratio of the Total Labor Force (in %) of Tonga in 1997 to that in 2002?
Your answer should be compact. 1.04. What is the ratio of the Total Labor Force (in %) in South Asia in 1997 to that in 2003?
Your answer should be compact. 1.02. What is the ratio of the Total Labor Force (in %) in India in 1997 to that in 2003?
Keep it short and to the point. 1.02. What is the ratio of the Total Labor Force (in %) in Iraq in 1997 to that in 2003?
Provide a succinct answer. 1.07. What is the ratio of the Total Labor Force (in %) in Tonga in 1997 to that in 2003?
Offer a very short reply. 1.03. What is the ratio of the Total Labor Force (in %) of India in 1998 to that in 1999?
Offer a terse response. 1.01. What is the ratio of the Total Labor Force (in %) in Iraq in 1998 to that in 1999?
Your answer should be compact. 1.01. What is the ratio of the Total Labor Force (in %) of Tonga in 1998 to that in 1999?
Provide a succinct answer. 1.01. What is the ratio of the Total Labor Force (in %) of South Asia in 1998 to that in 2000?
Offer a very short reply. 1.01. What is the ratio of the Total Labor Force (in %) in India in 1998 to that in 2000?
Provide a short and direct response. 1.02. What is the ratio of the Total Labor Force (in %) of Iraq in 1998 to that in 2000?
Your response must be concise. 1.02. What is the ratio of the Total Labor Force (in %) in Tonga in 1998 to that in 2000?
Ensure brevity in your answer.  1.02. What is the ratio of the Total Labor Force (in %) in South Asia in 1998 to that in 2001?
Provide a succinct answer. 1.01. What is the ratio of the Total Labor Force (in %) of India in 1998 to that in 2001?
Your answer should be compact. 1.01. What is the ratio of the Total Labor Force (in %) in Iraq in 1998 to that in 2001?
Keep it short and to the point. 1.03. What is the ratio of the Total Labor Force (in %) in Tonga in 1998 to that in 2001?
Ensure brevity in your answer.  1.02. What is the ratio of the Total Labor Force (in %) of South Asia in 1998 to that in 2002?
Provide a succinct answer. 1.01. What is the ratio of the Total Labor Force (in %) in India in 1998 to that in 2002?
Make the answer very short. 1.01. What is the ratio of the Total Labor Force (in %) in Iraq in 1998 to that in 2002?
Provide a short and direct response. 1.05. What is the ratio of the Total Labor Force (in %) in Tonga in 1998 to that in 2002?
Make the answer very short. 1.02. What is the ratio of the Total Labor Force (in %) in South Asia in 1998 to that in 2003?
Offer a terse response. 1.01. What is the ratio of the Total Labor Force (in %) of India in 1998 to that in 2003?
Offer a very short reply. 1.01. What is the ratio of the Total Labor Force (in %) of Iraq in 1998 to that in 2003?
Your response must be concise. 1.06. What is the ratio of the Total Labor Force (in %) of Tonga in 1998 to that in 2003?
Provide a short and direct response. 1.01. What is the ratio of the Total Labor Force (in %) in South Asia in 1999 to that in 2000?
Provide a succinct answer. 1.01. What is the ratio of the Total Labor Force (in %) of Iraq in 1999 to that in 2000?
Ensure brevity in your answer.  1.01. What is the ratio of the Total Labor Force (in %) of Tonga in 1999 to that in 2000?
Offer a terse response. 1.01. What is the ratio of the Total Labor Force (in %) of Iraq in 1999 to that in 2001?
Provide a succinct answer. 1.02. What is the ratio of the Total Labor Force (in %) of Tonga in 1999 to that in 2001?
Offer a terse response. 1.01. What is the ratio of the Total Labor Force (in %) of South Asia in 1999 to that in 2002?
Your response must be concise. 1.01. What is the ratio of the Total Labor Force (in %) in India in 1999 to that in 2002?
Your answer should be very brief. 1.01. What is the ratio of the Total Labor Force (in %) of Iraq in 1999 to that in 2002?
Your response must be concise. 1.04. What is the ratio of the Total Labor Force (in %) in Tonga in 1999 to that in 2002?
Your answer should be very brief. 1.01. What is the ratio of the Total Labor Force (in %) in Iraq in 1999 to that in 2003?
Provide a short and direct response. 1.05. What is the ratio of the Total Labor Force (in %) of Iraq in 2000 to that in 2001?
Offer a very short reply. 1.01. What is the ratio of the Total Labor Force (in %) in Tonga in 2000 to that in 2001?
Provide a short and direct response. 1. What is the ratio of the Total Labor Force (in %) in South Asia in 2000 to that in 2002?
Offer a terse response. 1. What is the ratio of the Total Labor Force (in %) in India in 2000 to that in 2002?
Offer a very short reply. 1. What is the ratio of the Total Labor Force (in %) of Iraq in 2000 to that in 2002?
Make the answer very short. 1.03. What is the ratio of the Total Labor Force (in %) in Tonga in 2000 to that in 2002?
Keep it short and to the point. 1. What is the ratio of the Total Labor Force (in %) in South Asia in 2000 to that in 2003?
Your answer should be compact. 1. What is the ratio of the Total Labor Force (in %) of India in 2000 to that in 2003?
Your answer should be compact. 1. What is the ratio of the Total Labor Force (in %) in Iraq in 2000 to that in 2003?
Your response must be concise. 1.04. What is the ratio of the Total Labor Force (in %) in Tonga in 2000 to that in 2003?
Keep it short and to the point. 1. What is the ratio of the Total Labor Force (in %) of South Asia in 2001 to that in 2002?
Provide a succinct answer. 1. What is the ratio of the Total Labor Force (in %) in Iraq in 2001 to that in 2002?
Your response must be concise. 1.01. What is the ratio of the Total Labor Force (in %) in India in 2001 to that in 2003?
Provide a succinct answer. 1. What is the ratio of the Total Labor Force (in %) in Iraq in 2001 to that in 2003?
Give a very brief answer. 1.03. What is the ratio of the Total Labor Force (in %) in Tonga in 2001 to that in 2003?
Provide a succinct answer. 0.99. What is the ratio of the Total Labor Force (in %) in South Asia in 2002 to that in 2003?
Keep it short and to the point. 1. What is the ratio of the Total Labor Force (in %) in India in 2002 to that in 2003?
Give a very brief answer. 1. What is the ratio of the Total Labor Force (in %) in Iraq in 2002 to that in 2003?
Make the answer very short. 1.01. What is the difference between the highest and the second highest Total Labor Force (in %) of South Asia?
Your answer should be compact. 0.39. What is the difference between the highest and the second highest Total Labor Force (in %) in Iraq?
Offer a very short reply. 0.5. What is the difference between the highest and the second highest Total Labor Force (in %) of Tonga?
Your response must be concise. 0.7. What is the difference between the highest and the lowest Total Labor Force (in %) in South Asia?
Offer a terse response. 1.49. What is the difference between the highest and the lowest Total Labor Force (in %) of India?
Make the answer very short. 2. What is the difference between the highest and the lowest Total Labor Force (in %) in Iraq?
Ensure brevity in your answer.  4.2. 